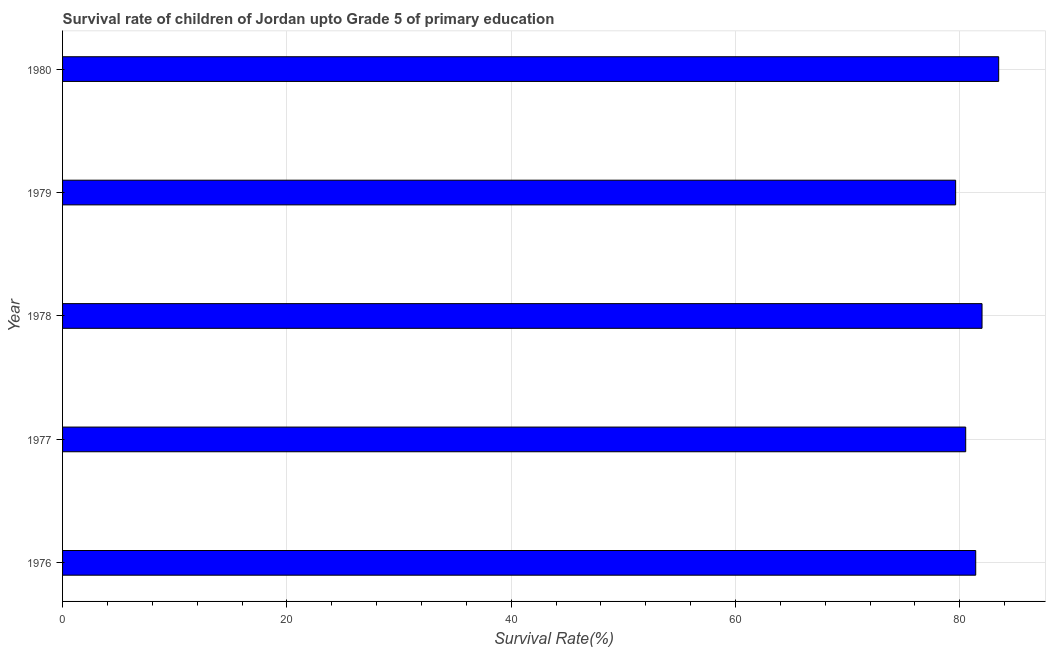Does the graph contain any zero values?
Your answer should be compact. No. What is the title of the graph?
Offer a very short reply. Survival rate of children of Jordan upto Grade 5 of primary education. What is the label or title of the X-axis?
Offer a very short reply. Survival Rate(%). What is the survival rate in 1979?
Keep it short and to the point. 79.63. Across all years, what is the maximum survival rate?
Ensure brevity in your answer.  83.47. Across all years, what is the minimum survival rate?
Your response must be concise. 79.63. In which year was the survival rate minimum?
Ensure brevity in your answer.  1979. What is the sum of the survival rate?
Provide a succinct answer. 407.05. What is the difference between the survival rate in 1977 and 1978?
Keep it short and to the point. -1.46. What is the average survival rate per year?
Give a very brief answer. 81.41. What is the median survival rate?
Your answer should be very brief. 81.43. What is the ratio of the survival rate in 1979 to that in 1980?
Keep it short and to the point. 0.95. Is the difference between the survival rate in 1976 and 1979 greater than the difference between any two years?
Provide a short and direct response. No. What is the difference between the highest and the second highest survival rate?
Your answer should be compact. 1.48. What is the difference between the highest and the lowest survival rate?
Offer a very short reply. 3.84. Are all the bars in the graph horizontal?
Offer a terse response. Yes. What is the difference between two consecutive major ticks on the X-axis?
Provide a short and direct response. 20. What is the Survival Rate(%) in 1976?
Offer a very short reply. 81.43. What is the Survival Rate(%) in 1977?
Your answer should be very brief. 80.53. What is the Survival Rate(%) in 1978?
Make the answer very short. 81.99. What is the Survival Rate(%) in 1979?
Ensure brevity in your answer.  79.63. What is the Survival Rate(%) in 1980?
Your response must be concise. 83.47. What is the difference between the Survival Rate(%) in 1976 and 1977?
Provide a succinct answer. 0.89. What is the difference between the Survival Rate(%) in 1976 and 1978?
Your answer should be very brief. -0.56. What is the difference between the Survival Rate(%) in 1976 and 1979?
Offer a very short reply. 1.79. What is the difference between the Survival Rate(%) in 1976 and 1980?
Offer a terse response. -2.05. What is the difference between the Survival Rate(%) in 1977 and 1978?
Provide a succinct answer. -1.46. What is the difference between the Survival Rate(%) in 1977 and 1979?
Ensure brevity in your answer.  0.9. What is the difference between the Survival Rate(%) in 1977 and 1980?
Provide a short and direct response. -2.94. What is the difference between the Survival Rate(%) in 1978 and 1979?
Give a very brief answer. 2.35. What is the difference between the Survival Rate(%) in 1978 and 1980?
Offer a very short reply. -1.48. What is the difference between the Survival Rate(%) in 1979 and 1980?
Keep it short and to the point. -3.84. What is the ratio of the Survival Rate(%) in 1976 to that in 1978?
Offer a terse response. 0.99. What is the ratio of the Survival Rate(%) in 1977 to that in 1979?
Your answer should be compact. 1.01. What is the ratio of the Survival Rate(%) in 1977 to that in 1980?
Make the answer very short. 0.96. What is the ratio of the Survival Rate(%) in 1978 to that in 1979?
Your answer should be compact. 1.03. What is the ratio of the Survival Rate(%) in 1978 to that in 1980?
Provide a succinct answer. 0.98. What is the ratio of the Survival Rate(%) in 1979 to that in 1980?
Offer a terse response. 0.95. 